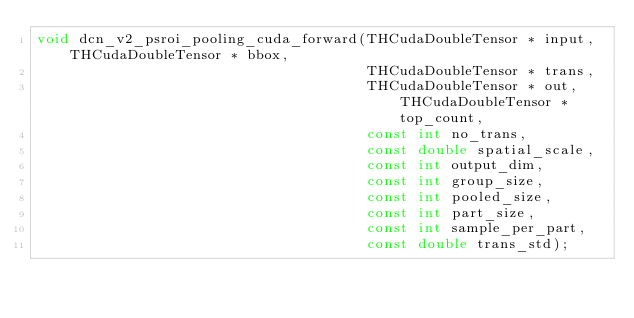<code> <loc_0><loc_0><loc_500><loc_500><_C_>void dcn_v2_psroi_pooling_cuda_forward(THCudaDoubleTensor * input, THCudaDoubleTensor * bbox,
                                       THCudaDoubleTensor * trans, 
                                       THCudaDoubleTensor * out, THCudaDoubleTensor * top_count,
                                       const int no_trans,
                                       const double spatial_scale,
                                       const int output_dim,
                                       const int group_size,
                                       const int pooled_size,
                                       const int part_size,
                                       const int sample_per_part,
                                       const double trans_std);
</code> 